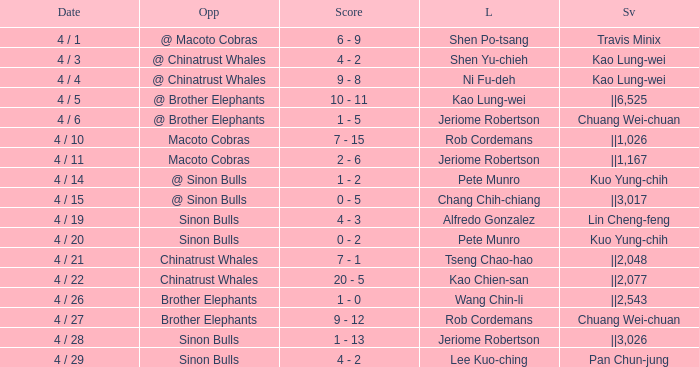Who earned the save in the game against the Sinon Bulls when Jeriome Robertson took the loss? ||3,026. 